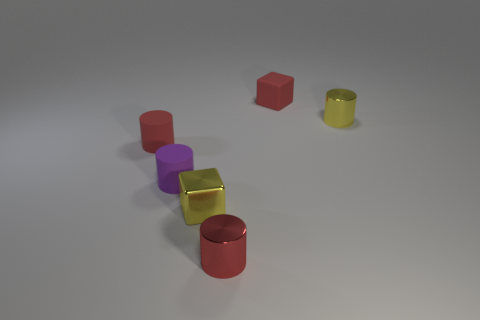Is the material of the tiny yellow thing in front of the red rubber cylinder the same as the small red thing that is on the right side of the red shiny cylinder?
Offer a terse response. No. Is the number of blocks behind the small red rubber cylinder less than the number of tiny yellow cubes?
Your response must be concise. No. What color is the small shiny cylinder behind the metallic cube?
Make the answer very short. Yellow. There is a tiny red thing left of the red cylinder that is in front of the tiny yellow metallic cube; what is its material?
Your answer should be compact. Rubber. Is there a rubber thing of the same size as the purple rubber cylinder?
Your answer should be compact. Yes. How many objects are either yellow objects in front of the yellow cylinder or tiny red matte objects that are left of the shiny cube?
Give a very brief answer. 2. There is a metallic cylinder right of the red cube; is it the same size as the purple thing that is to the left of the red block?
Make the answer very short. Yes. There is a red matte thing in front of the yellow cylinder; are there any rubber cylinders right of it?
Your answer should be compact. Yes. There is a tiny red metal thing; what number of yellow shiny objects are to the right of it?
Offer a very short reply. 1. How many other objects are the same color as the matte cube?
Keep it short and to the point. 2. 